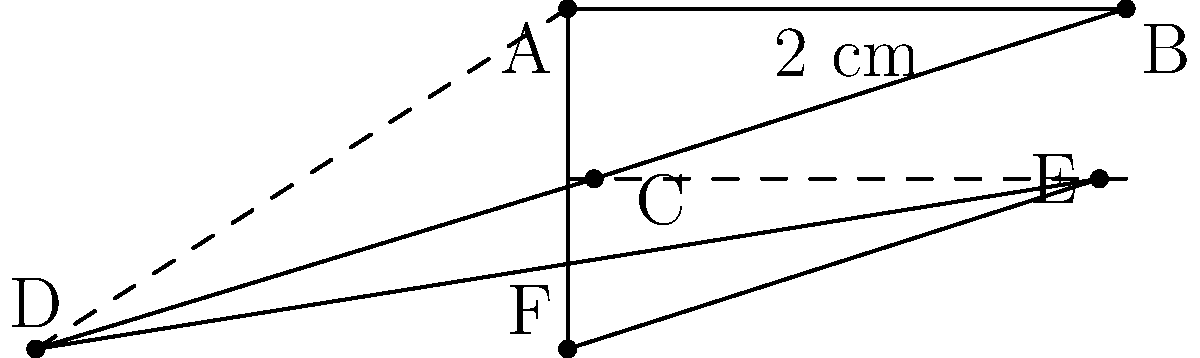A hexagonal contact lens case has the shape shown in the figure above. If the length of each side is 2 cm, what is the perimeter of the case? To find the perimeter of the hexagonal contact lens case, we need to follow these steps:

1. Identify the shape: The case is a regular hexagon, meaning all sides are equal in length.

2. Count the number of sides: A hexagon has 6 sides.

3. Note the length of each side: Given in the question as 2 cm.

4. Calculate the perimeter: The perimeter of a polygon is the sum of the lengths of all its sides.

   For a regular hexagon: Perimeter = 6 * side length

   Perimeter = $6 \times 2$ cm = $12$ cm

Therefore, the perimeter of the hexagonal contact lens case is 12 cm.
Answer: 12 cm 